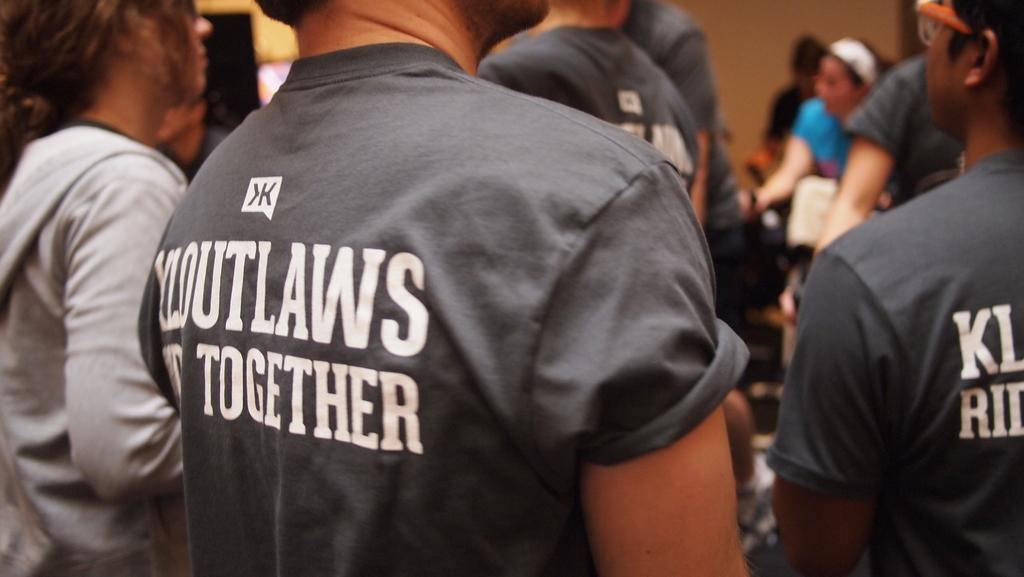Can you describe this image briefly? In the picture we can see some people are standing in black T-shirts and something written on it and beside them, we can see a woman standing in a white hoodie and in the background, we can see a woman standing in blue T-shirt and behind her we can see a wall. 